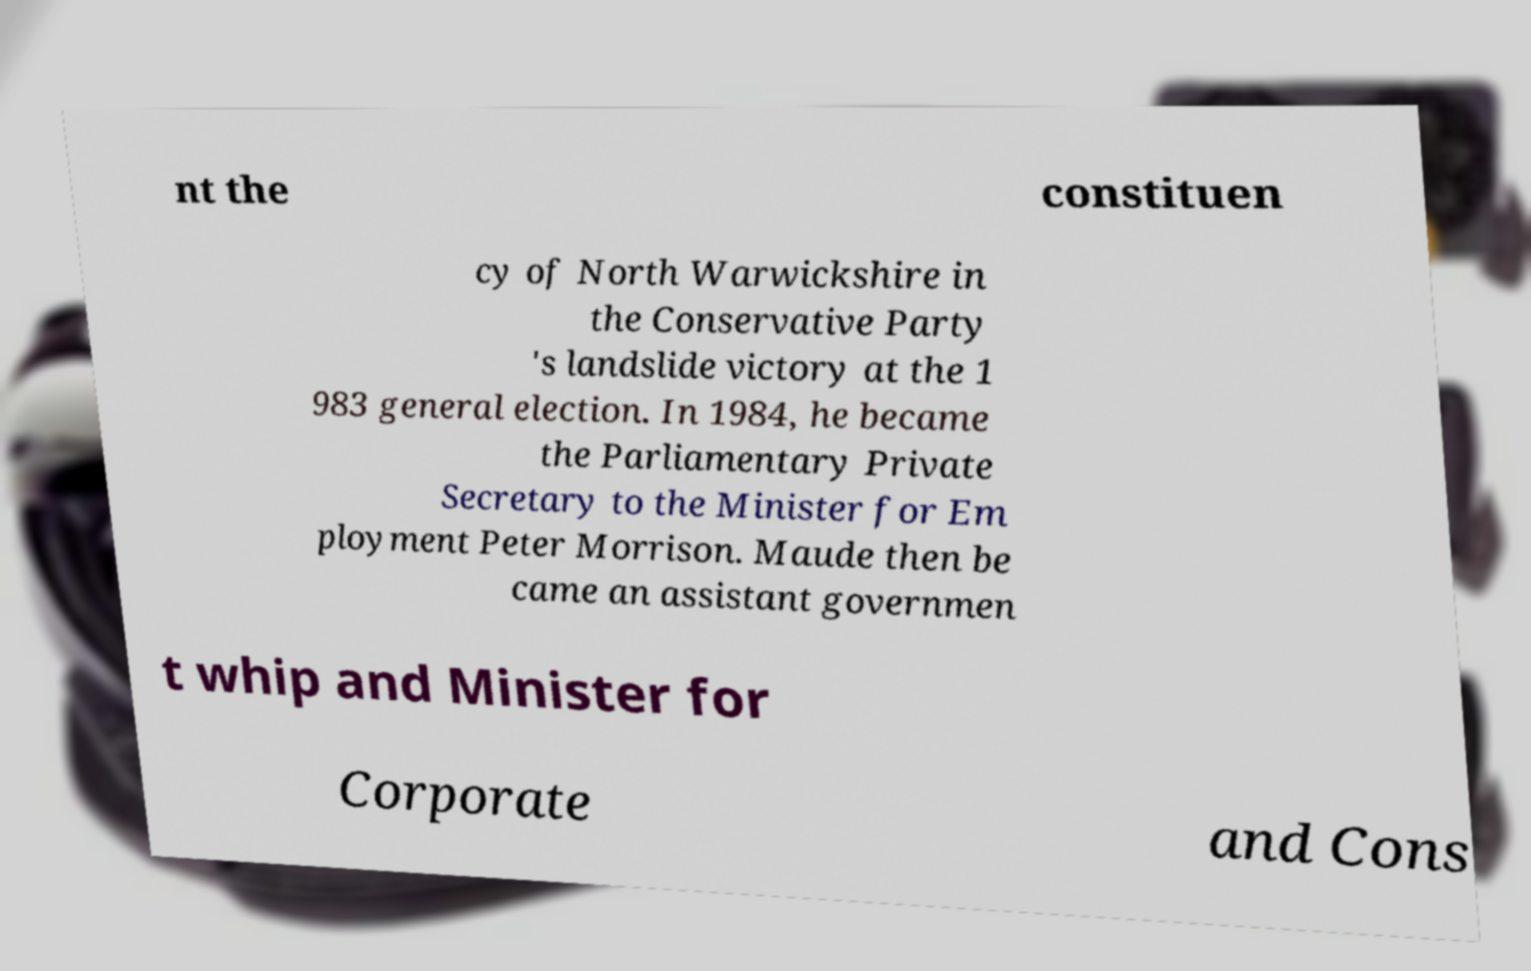For documentation purposes, I need the text within this image transcribed. Could you provide that? nt the constituen cy of North Warwickshire in the Conservative Party 's landslide victory at the 1 983 general election. In 1984, he became the Parliamentary Private Secretary to the Minister for Em ployment Peter Morrison. Maude then be came an assistant governmen t whip and Minister for Corporate and Cons 